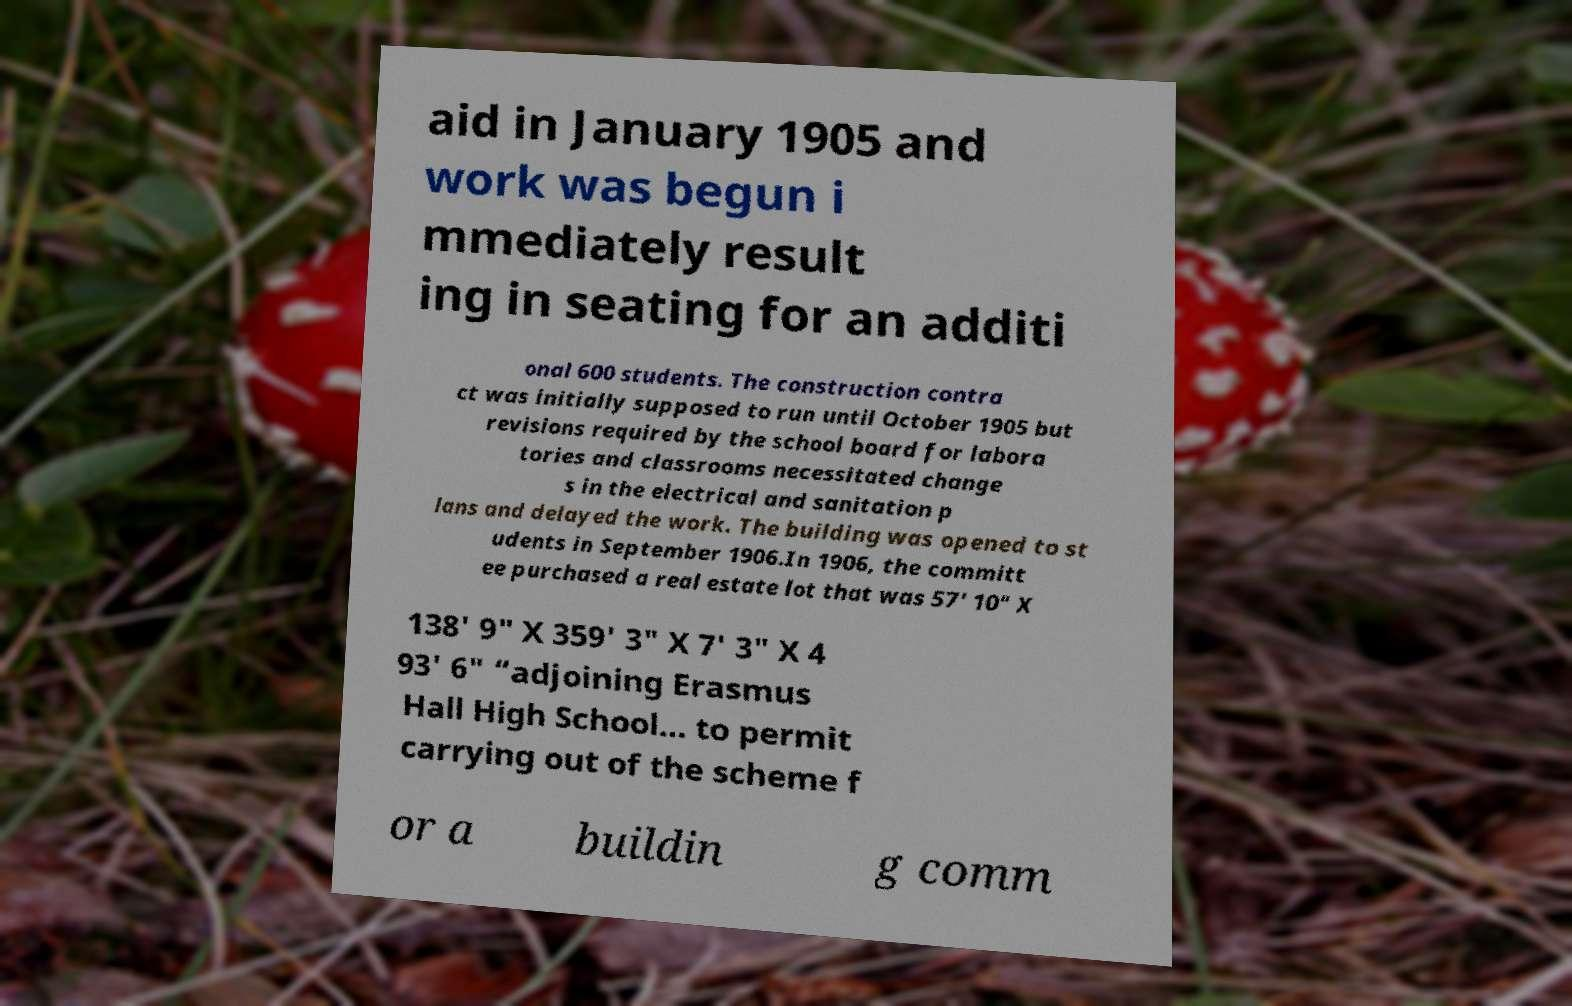For documentation purposes, I need the text within this image transcribed. Could you provide that? aid in January 1905 and work was begun i mmediately result ing in seating for an additi onal 600 students. The construction contra ct was initially supposed to run until October 1905 but revisions required by the school board for labora tories and classrooms necessitated change s in the electrical and sanitation p lans and delayed the work. The building was opened to st udents in September 1906.In 1906, the committ ee purchased a real estate lot that was 57' 10" X 138' 9" X 359' 3" X 7' 3" X 4 93' 6" “adjoining Erasmus Hall High School... to permit carrying out of the scheme f or a buildin g comm 